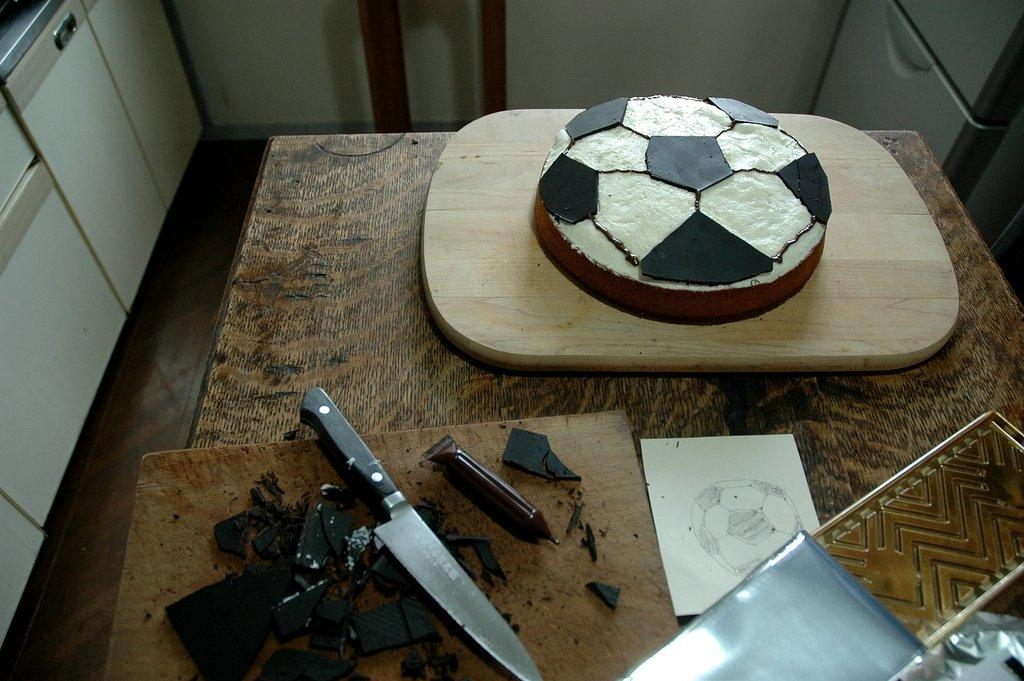What piece of furniture is present in the image? There is a table in the image. What is placed on the table? There is a cake on the table. What utensil is also present on the table? There is a knife on the table. What type of ship can be seen sailing in the background of the image? There is no ship present in the image; it only features a table, a cake, and a knife. 